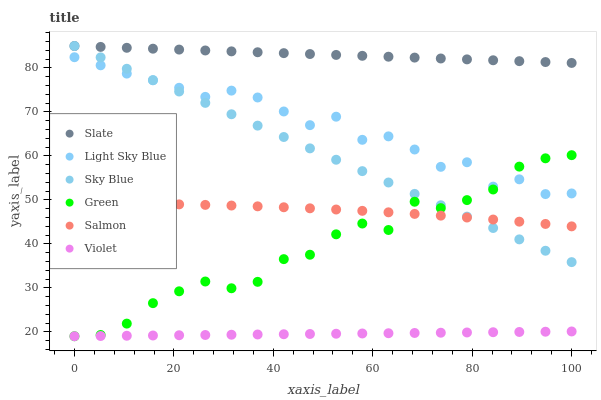Does Violet have the minimum area under the curve?
Answer yes or no. Yes. Does Slate have the maximum area under the curve?
Answer yes or no. Yes. Does Salmon have the minimum area under the curve?
Answer yes or no. No. Does Salmon have the maximum area under the curve?
Answer yes or no. No. Is Violet the smoothest?
Answer yes or no. Yes. Is Light Sky Blue the roughest?
Answer yes or no. Yes. Is Salmon the smoothest?
Answer yes or no. No. Is Salmon the roughest?
Answer yes or no. No. Does Green have the lowest value?
Answer yes or no. Yes. Does Salmon have the lowest value?
Answer yes or no. No. Does Sky Blue have the highest value?
Answer yes or no. Yes. Does Salmon have the highest value?
Answer yes or no. No. Is Salmon less than Slate?
Answer yes or no. Yes. Is Slate greater than Violet?
Answer yes or no. Yes. Does Light Sky Blue intersect Sky Blue?
Answer yes or no. Yes. Is Light Sky Blue less than Sky Blue?
Answer yes or no. No. Is Light Sky Blue greater than Sky Blue?
Answer yes or no. No. Does Salmon intersect Slate?
Answer yes or no. No. 